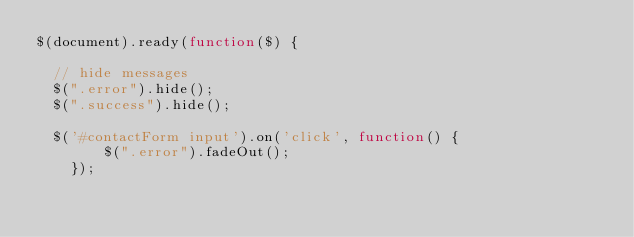<code> <loc_0><loc_0><loc_500><loc_500><_JavaScript_>$(document).ready(function($) {

	// hide messages 
	$(".error").hide();
	$(".success").hide();
	
	$('#contactForm input').on('click', function() {
        $(".error").fadeOut();
    });
	</code> 